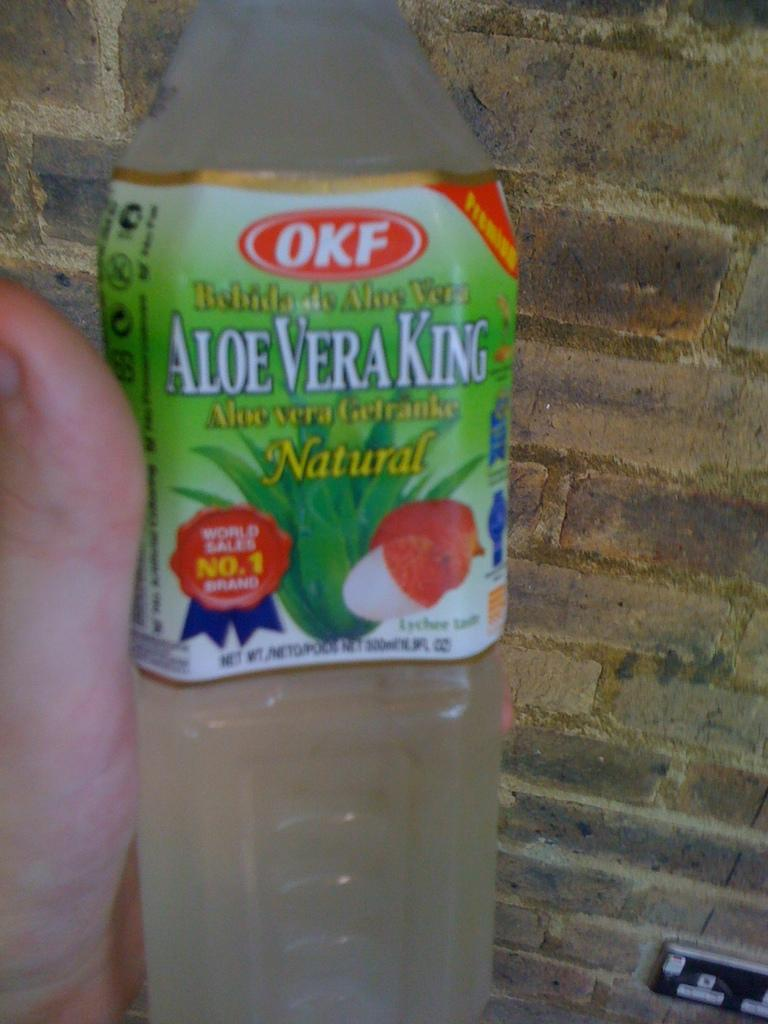What object is being held by the person's hand in the image? There is a plastic water bottle being held by the person's hand in the image. What can be seen in the background of the image? There is a wall visible in the background of the image. What type of curve can be seen in the person's thought process in the image? There is no indication of the person's thought process in the image, and therefore no curve can be observed. 